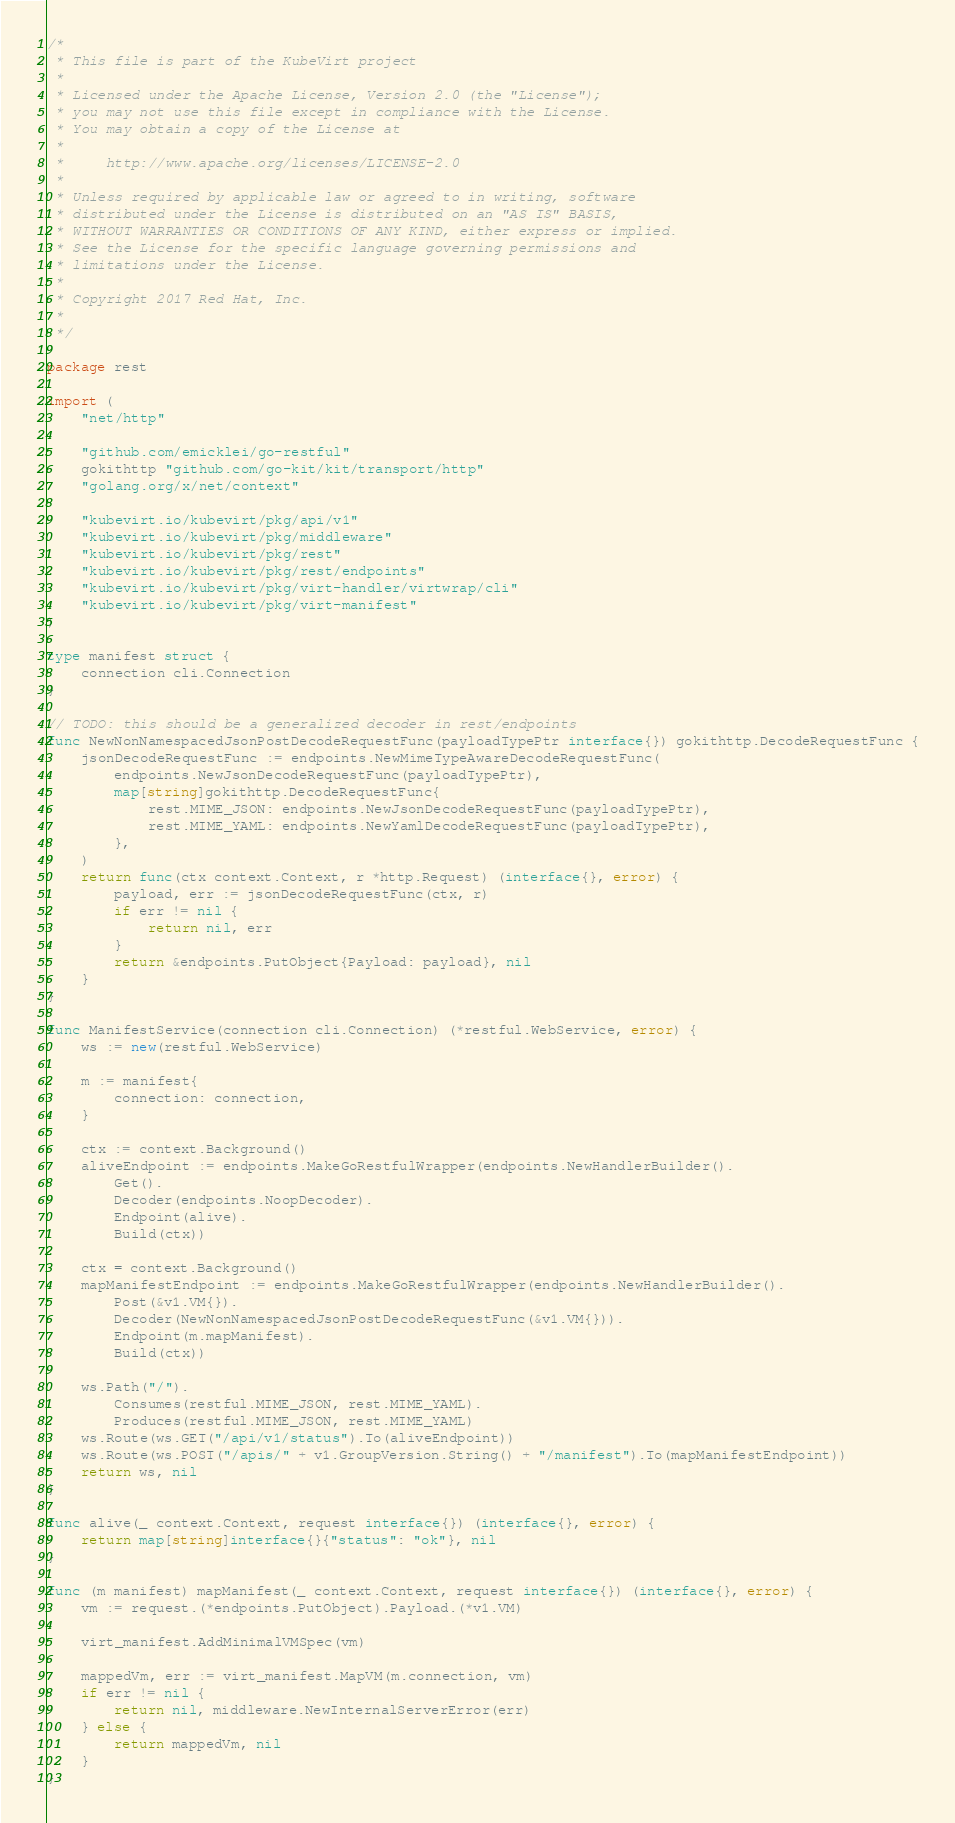Convert code to text. <code><loc_0><loc_0><loc_500><loc_500><_Go_>/*
 * This file is part of the KubeVirt project
 *
 * Licensed under the Apache License, Version 2.0 (the "License");
 * you may not use this file except in compliance with the License.
 * You may obtain a copy of the License at
 *
 *     http://www.apache.org/licenses/LICENSE-2.0
 *
 * Unless required by applicable law or agreed to in writing, software
 * distributed under the License is distributed on an "AS IS" BASIS,
 * WITHOUT WARRANTIES OR CONDITIONS OF ANY KIND, either express or implied.
 * See the License for the specific language governing permissions and
 * limitations under the License.
 *
 * Copyright 2017 Red Hat, Inc.
 *
 */

package rest

import (
	"net/http"

	"github.com/emicklei/go-restful"
	gokithttp "github.com/go-kit/kit/transport/http"
	"golang.org/x/net/context"

	"kubevirt.io/kubevirt/pkg/api/v1"
	"kubevirt.io/kubevirt/pkg/middleware"
	"kubevirt.io/kubevirt/pkg/rest"
	"kubevirt.io/kubevirt/pkg/rest/endpoints"
	"kubevirt.io/kubevirt/pkg/virt-handler/virtwrap/cli"
	"kubevirt.io/kubevirt/pkg/virt-manifest"
)

type manifest struct {
	connection cli.Connection
}

// TODO: this should be a generalized decoder in rest/endpoints
func NewNonNamespacedJsonPostDecodeRequestFunc(payloadTypePtr interface{}) gokithttp.DecodeRequestFunc {
	jsonDecodeRequestFunc := endpoints.NewMimeTypeAwareDecodeRequestFunc(
		endpoints.NewJsonDecodeRequestFunc(payloadTypePtr),
		map[string]gokithttp.DecodeRequestFunc{
			rest.MIME_JSON: endpoints.NewJsonDecodeRequestFunc(payloadTypePtr),
			rest.MIME_YAML: endpoints.NewYamlDecodeRequestFunc(payloadTypePtr),
		},
	)
	return func(ctx context.Context, r *http.Request) (interface{}, error) {
		payload, err := jsonDecodeRequestFunc(ctx, r)
		if err != nil {
			return nil, err
		}
		return &endpoints.PutObject{Payload: payload}, nil
	}
}

func ManifestService(connection cli.Connection) (*restful.WebService, error) {
	ws := new(restful.WebService)

	m := manifest{
		connection: connection,
	}

	ctx := context.Background()
	aliveEndpoint := endpoints.MakeGoRestfulWrapper(endpoints.NewHandlerBuilder().
		Get().
		Decoder(endpoints.NoopDecoder).
		Endpoint(alive).
		Build(ctx))

	ctx = context.Background()
	mapManifestEndpoint := endpoints.MakeGoRestfulWrapper(endpoints.NewHandlerBuilder().
		Post(&v1.VM{}).
		Decoder(NewNonNamespacedJsonPostDecodeRequestFunc(&v1.VM{})).
		Endpoint(m.mapManifest).
		Build(ctx))

	ws.Path("/").
		Consumes(restful.MIME_JSON, rest.MIME_YAML).
		Produces(restful.MIME_JSON, rest.MIME_YAML)
	ws.Route(ws.GET("/api/v1/status").To(aliveEndpoint))
	ws.Route(ws.POST("/apis/" + v1.GroupVersion.String() + "/manifest").To(mapManifestEndpoint))
	return ws, nil
}

func alive(_ context.Context, request interface{}) (interface{}, error) {
	return map[string]interface{}{"status": "ok"}, nil
}

func (m manifest) mapManifest(_ context.Context, request interface{}) (interface{}, error) {
	vm := request.(*endpoints.PutObject).Payload.(*v1.VM)

	virt_manifest.AddMinimalVMSpec(vm)

	mappedVm, err := virt_manifest.MapVM(m.connection, vm)
	if err != nil {
		return nil, middleware.NewInternalServerError(err)
	} else {
		return mappedVm, nil
	}
}
</code> 